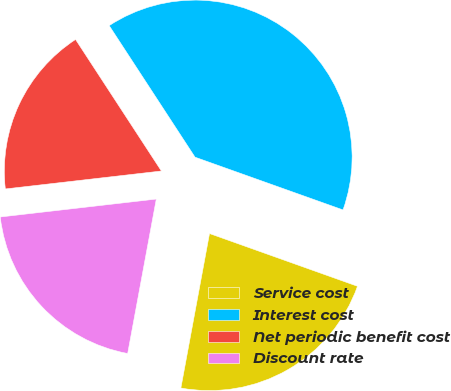Convert chart. <chart><loc_0><loc_0><loc_500><loc_500><pie_chart><fcel>Service cost<fcel>Interest cost<fcel>Net periodic benefit cost<fcel>Discount rate<nl><fcel>22.47%<fcel>39.65%<fcel>17.62%<fcel>20.26%<nl></chart> 